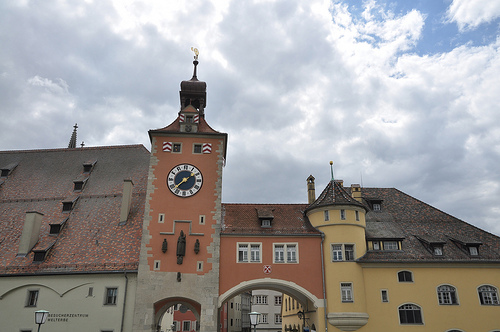What kinds of activities might people be doing in these buildings? People might be engaged in a variety of activities such as attending town meetings, shopping at local stores, eating at cozy restaurants, working in offices or artisanal workshops, and living in quaint apartments. Describe a day in the life of a person living in one of these buildings. A typical day might start with the person waking up to the sound of church bells and the scent of fresh bread wafting through the air. They have breakfast while looking out at the bustling market square below. The morning is spent working in a local shop or office. Lunchtime is enjoyed at a nearby café with friends. The afternoon involves running errands, perhaps visiting the post office or buying groceries at the market. Evenings are for family time, cooking dinner together and relaxing. The day ends with a quiet walk through the now peaceful square, reflecting on the day's happenings. What's happening inside the clock tower? Inside the clock tower, large gears and pendulums work in harmony to keep the clock running accurately. There may be a staircase or a series of ladders leading up to the top where one can get a panoramic view of the town. Occasionally, a watchmaker or maintenance worker might be found here, ensuring that the mechanisms operate smoothly and the time displayed is correct. Imagine there's a hidden treasure hidden within one of these buildings. Where would it be and what's the story behind it? Legend has it that during a great war, the town's wealthiest merchant hid his treasures in a secret chamber of his home, fearing it would be stolen by invaders. The chamber, accessible only through a hidden panel behind the largest bookshelf, contains ancient coins, jewelry, and precious artifacts. The treasure has remained undiscovered for centuries, passed down through hushed stories and whisperings. It's said that the merchant's spirit still guards it, waiting for someone worthy to find it and safeguard the town's legacy. 